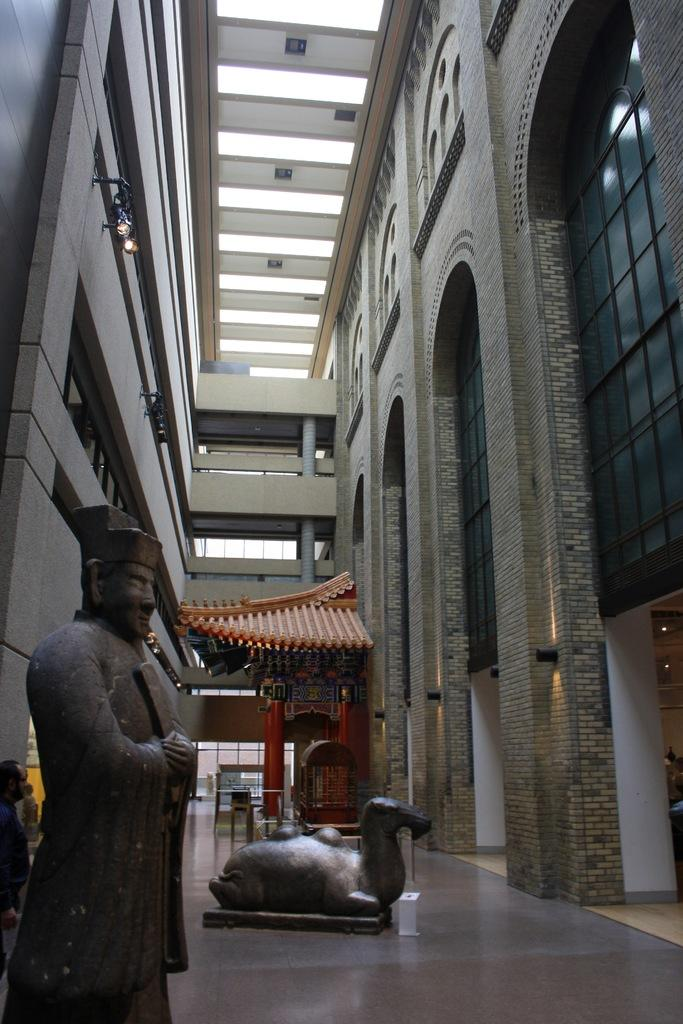What type of structure can be seen in the image? There is a wall, a roof, and pillars with arches in the image, which suggests a building or architectural structure. Are there any decorative elements in the image? Yes, there are statues in the image, which can be considered decorative elements. What type of lighting is present in the image? There are lights in the image, which could be used for illumination or decoration. Can you describe the person in the image? One person is standing in the image, but no specific details about their appearance or clothing are provided. What other objects can be seen in the image? There are other objects in the image, but their nature is not specified in the provided facts. How does the coastline affect the appearance of the hen in the image? There is no hen present in the image, and therefore no coastline can affect its appearance. 